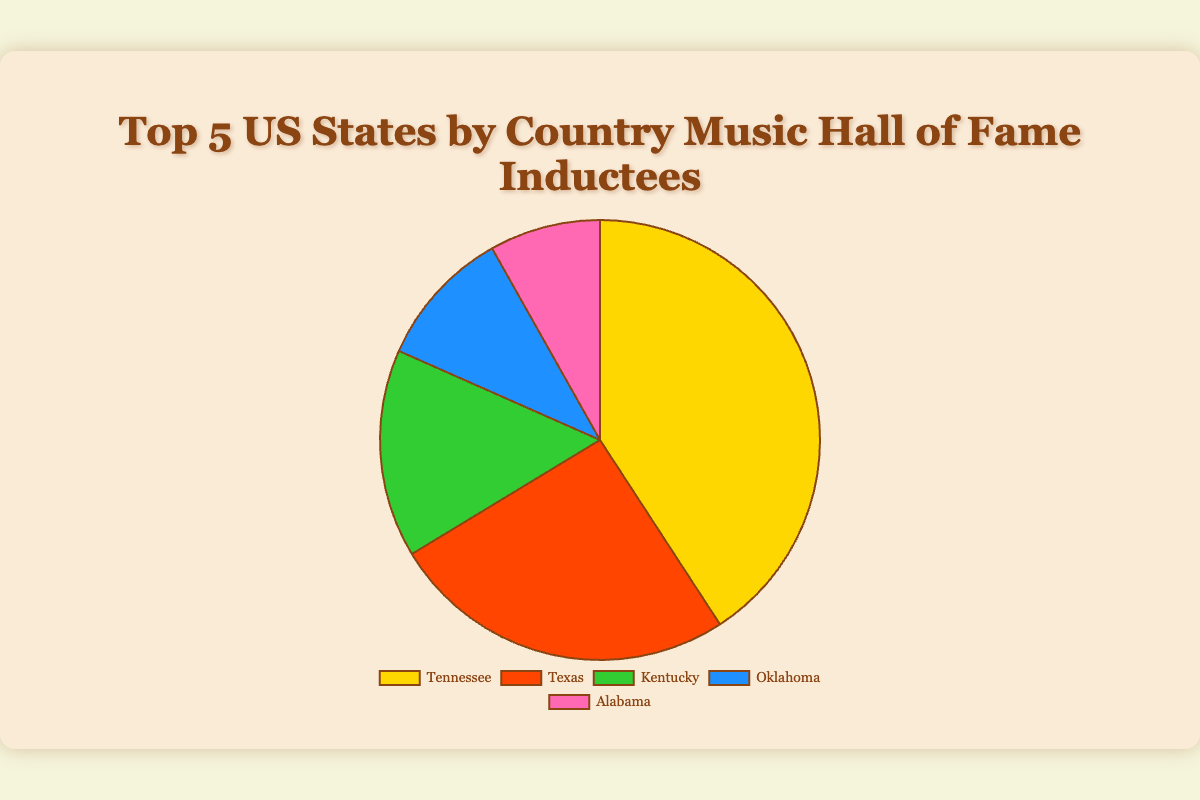What's the state with the highest number of Country Music Hall of Fame inductees? The pie chart shows that Tennessee has the largest portion. This indicates that Tennessee has the highest number of inductees among the states listed.
Answer: Tennessee By how much does Tennessee surpass Texas in the number of inductees? From the chart, Tennessee has 40 inductees and Texas has 25. The difference is calculated as 40 - 25.
Answer: 15 Which state has the smallest number of Country Music Hall of Fame inductees? The smallest portion of the pie chart represents Alabama, indicating it has the fewest inductees.
Answer: Alabama What is the combined number of inductees from Kentucky and Oklahoma? Kentucky has 15 inductees, and Oklahoma has 10 inductees. Adding these gives 15 + 10.
Answer: 25 If you combine the number of inductees from Alabama and Oklahoma, how much more or less is this compared to Texas? Alabama has 8 inductees and Oklahoma has 10, combining gives 8 + 10 = 18. Texas has 25, so the difference is 25 - 18.
Answer: 7 Which two states have a combined total equal to the number of inductees from Texas? Kentucky (15) and Oklahoma (10) together have 15 + 10 = 25, which equals the number of inductees from Texas.
Answer: Kentucky and Oklahoma By what percentage does Tennessee exceed Oklahoma in the number of inductees? Tennessee has 40 inductees and Oklahoma has 10. The percentage difference is calculated as ((40 - 10) / 10) * 100.
Answer: 300% What is the ratio of the number of inductees in Tennessee to those in Alabama? Tennessee has 40 inductees and Alabama has 8. The ratio is 40:8, which simplifies to 5:1.
Answer: 5:1 Which color represents Texas on the pie chart? The pie chart uses specific colors for each state. By referring to the chart legend, Texas is represented by the color red.
Answer: Red What is the average number of inductees across these five states? The total number of inductees is 40 + 25 + 15 + 10 + 8 = 98. There are 5 states, so the average is 98 / 5.
Answer: 19.6 